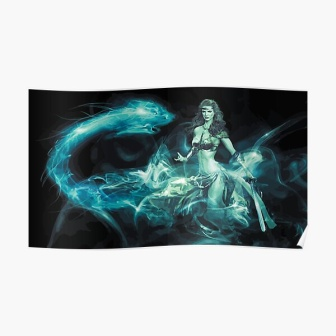Write a detailed description of the given image. In the center of this digital art piece, a woman with long, flowing hair takes the spotlight. She is garbed in an ethereal white dress which contrasts sharply against the dark, almost black background, giving her an aura of purity and mystique. In her right hand, she grasps a sword, its blade angled downwards, hinting at an aura of readiness or perhaps a sense of protection and defense.

The most captivating element of the image is the swirling blue smoke that ensnares and dances around the woman. This smoke seems almost alive, as though it forms a protective shroud or an extension of her own mystical power. One particularly large tendril of the smoke extends towards the left side of the image, adding a dynamic sense of movement and energy to the piece.

Despite the fantastical elements, the image is devoid of any discernible text or countable objects. The relative positioning of the objects is clear: the woman stands prominently in the foreground, enveloped in the magical, blue smoke against the vast, black backdrop. The image refrains from offering additional context or setting, allowing the viewer to immerse themselves in the enigmatic and magical aura of the scene. 